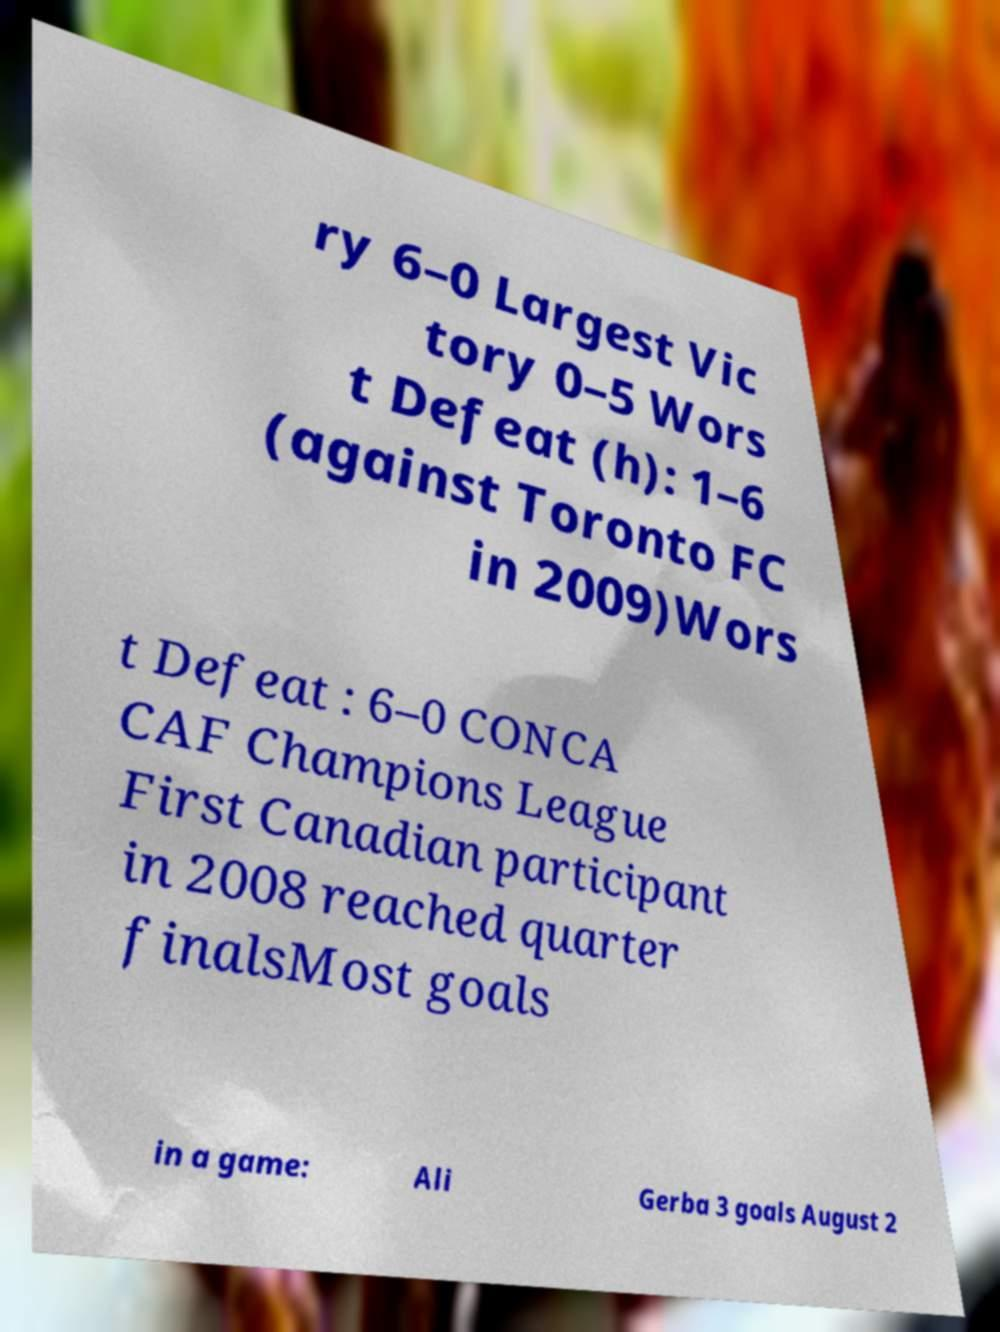Could you assist in decoding the text presented in this image and type it out clearly? ry 6–0 Largest Vic tory 0–5 Wors t Defeat (h): 1–6 (against Toronto FC in 2009)Wors t Defeat : 6–0 CONCA CAF Champions League First Canadian participant in 2008 reached quarter finalsMost goals in a game: Ali Gerba 3 goals August 2 